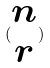<formula> <loc_0><loc_0><loc_500><loc_500>( \begin{matrix} n \\ r \end{matrix} )</formula> 